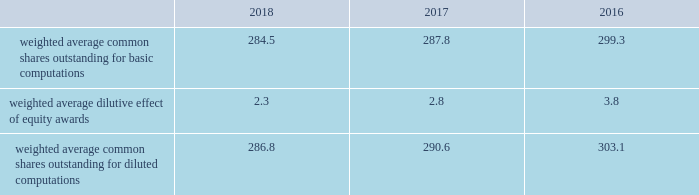Note 2 2013 earnings per share the weighted average number of shares outstanding used to compute earnings per common share were as follows ( in millions ) : .
We compute basic and diluted earnings per common share by dividing net earnings by the respective weighted average number of common shares outstanding for the periods presented .
Our calculation of diluted earnings per common share also includes the dilutive effects for the assumed vesting of outstanding restricted stock units ( rsus ) , performance stock units ( psus ) and exercise of outstanding stock options based on the treasury stock method .
There were no significant anti-dilutive equity awards for the years ended december 31 , 2018 , 2017 and 2016 .
Note 3 2013 acquisition and divestitures consolidation of awe management limited on august 24 , 2016 , we increased our ownership interest in the awe joint venture , which operates the united kingdom 2019s nuclear deterrent program , from 33% ( 33 % ) to 51% ( 51 % ) .
Consequently , we began consolidating awe and our operating results include 100% ( 100 % ) of awe 2019s sales and 51% ( 51 % ) of its operating profit .
Prior to increasing our ownership interest , we accounted for our investment in awe using the equity method of accounting .
Under the equity method , we recognized only 33% ( 33 % ) of awe 2019s earnings or losses and no sales .
Accordingly , prior to august 24 , 2016 , the date we obtained control , we recorded 33% ( 33 % ) of awe 2019s net earnings in our operating results and subsequent to august 24 , 2016 , we recognized 100% ( 100 % ) of awe 2019s sales and 51% ( 51 % ) of its operating profit .
We accounted for this transaction as a 201cstep acquisition 201d ( as defined by u.s .
Gaap ) , which requires us to consolidate and record the assets and liabilities of awe at fair value .
Accordingly , we recorded intangible assets of $ 243 million related to customer relationships , $ 32 million of net liabilities , and noncontrolling interests of $ 107 million .
The intangible assets are being amortized over a period of eight years in accordance with the underlying pattern of economic benefit reflected by the future net cash flows .
In 2016 , we recognized a non-cash net gain of $ 104 million associated with obtaining a controlling interest in awe , which consisted of a $ 127 million pretax gain recognized in the operating results of our space business segment and $ 23 million of tax-related items at our corporate office .
The gain represented the fair value of our 51% ( 51 % ) interest in awe , less the carrying value of our previously held investment in awe and deferred taxes .
The gain was recorded in other income , net on our consolidated statements of earnings .
The fair value of awe ( including the intangible assets ) , our controlling interest , and the noncontrolling interests were determined using the income approach .
Divestiture of the information systems & global solutions business on august 16 , 2016 , we divested our former is&gs business , which merged with leidos , in a reverse morris trust transaction ( the 201ctransaction 201d ) .
The transaction was completed in a multi-step process pursuant to which we initially contributed the is&gs business to abacus innovations corporation ( abacus ) , a wholly owned subsidiary of lockheed martin created to facilitate the transaction , and the common stock of abacus was distributed to participating lockheed martin stockholders through an exchange offer .
Under the terms of the exchange offer , lockheed martin stockholders had the option to exchange shares of lockheed martin common stock for shares of abacus common stock .
At the conclusion of the exchange offer , all shares of abacus common stock were exchanged for 9369694 shares of lockheed martin common stock held by lockheed martin stockholders that elected to participate in the exchange .
The shares of lockheed martin common stock that were exchanged and accepted were retired , reducing the number of shares of our common stock outstanding by approximately 3% ( 3 % ) .
Following the exchange offer , abacus merged with a subsidiary of leidos , with abacus continuing as the surviving corporation and a wholly-owned subsidiary of leidos .
As part of the merger , each share of abacus common stock was automatically converted into one share of leidos common stock .
We did not receive any shares of leidos common stock as part of the transaction and do not hold any shares of leidos or abacus common stock following the transaction .
Based on an opinion of outside tax counsel , subject to customary qualifications and based on factual representations , the exchange offer and merger will qualify as tax-free transactions to lockheed martin and its stockholders , except to the extent that cash was paid to lockheed martin stockholders in lieu of fractional shares .
In connection with the transaction , abacus borrowed an aggregate principal amount of approximately $ 1.84 billion under term loan facilities with third party financial institutions , the proceeds of which were used to make a one-time special cash payment of $ 1.80 billion to lockheed martin and to pay associated borrowing fees and expenses .
The entire special cash payment was used to repay debt , pay dividends and repurchase stock during the third and fourth quarters of 2016 .
The obligations under the abacus term loan facilities were guaranteed by leidos as part of the transaction. .
What is the percentage change in weighted average common shares outstanding for basic computations from 2016 to 2017? 
Computations: ((287.8 - 299.3) / 299.3)
Answer: -0.03842. 